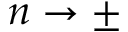Convert formula to latex. <formula><loc_0><loc_0><loc_500><loc_500>n \rightarrow \pm</formula> 